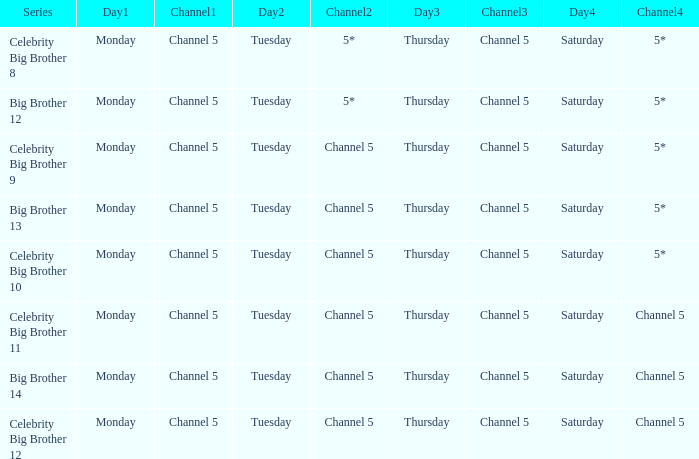Which series airs Saturday on Channel 5? Celebrity Big Brother 11, Big Brother 14, Celebrity Big Brother 12. 